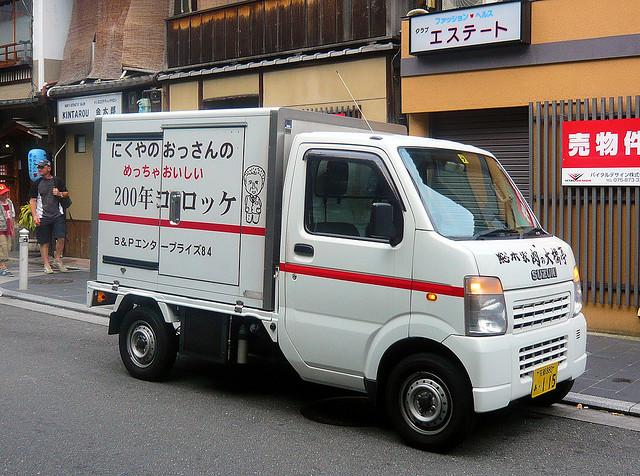What temperature items might be carried by this truck?

Choices:
A) cold
B) all
C) room
D) none cold 